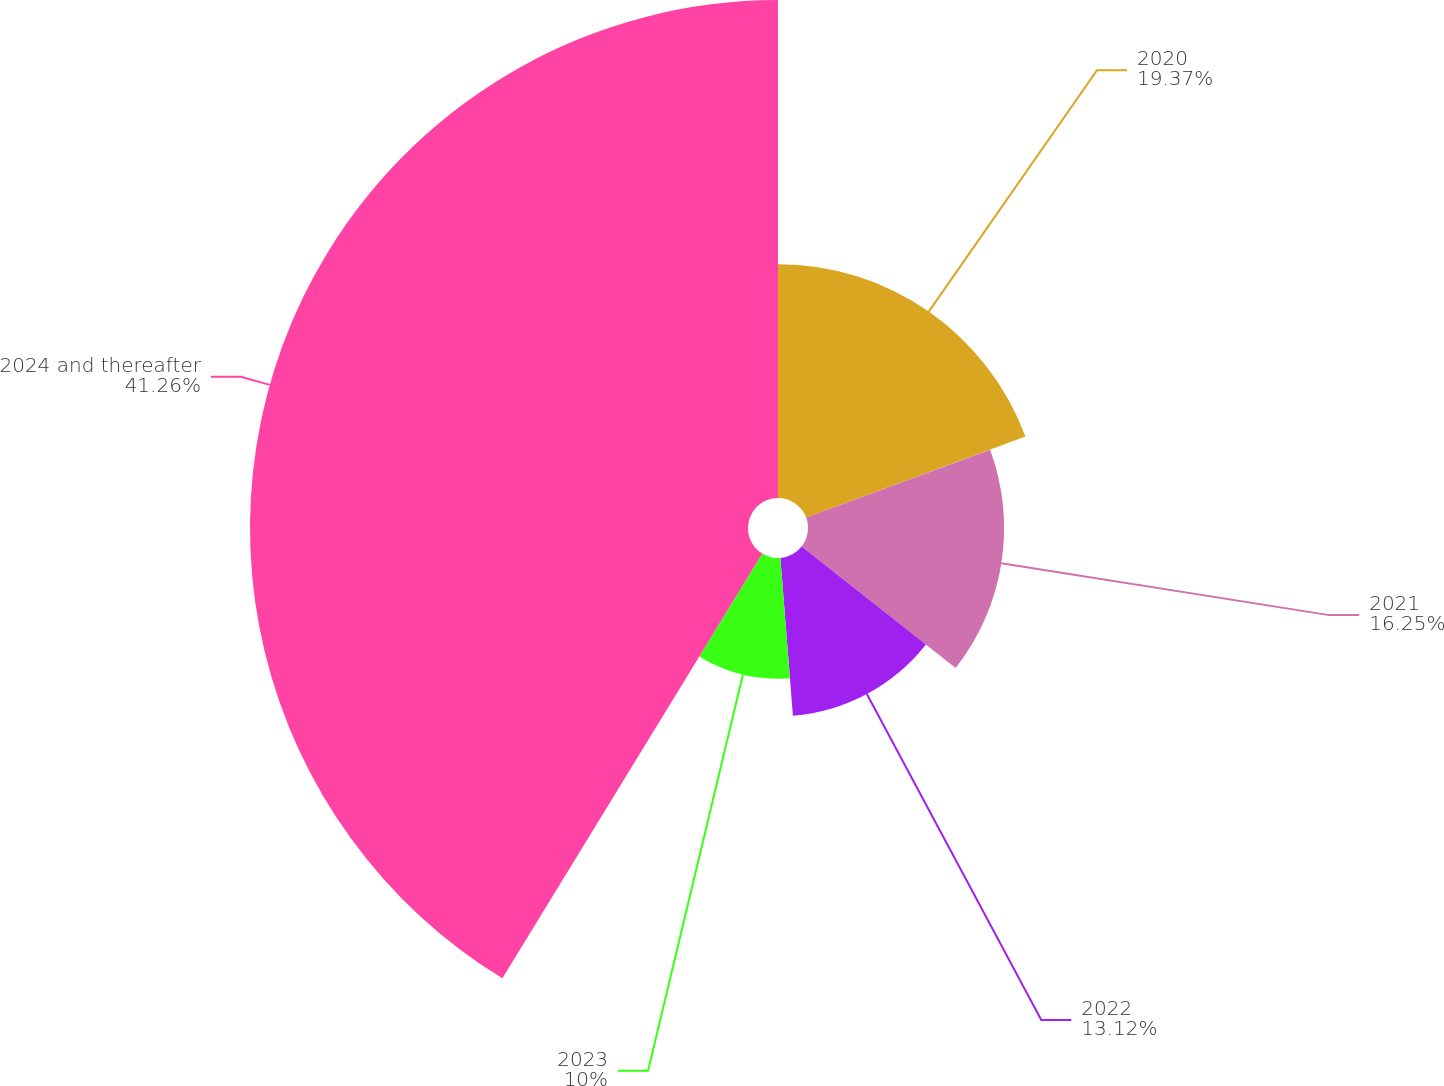<chart> <loc_0><loc_0><loc_500><loc_500><pie_chart><fcel>2020<fcel>2021<fcel>2022<fcel>2023<fcel>2024 and thereafter<nl><fcel>19.37%<fcel>16.25%<fcel>13.12%<fcel>10.0%<fcel>41.26%<nl></chart> 